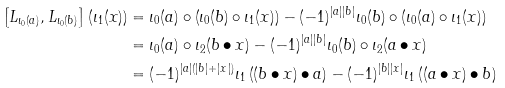<formula> <loc_0><loc_0><loc_500><loc_500>\left [ L _ { \iota _ { 0 } ( a ) } , L _ { \iota _ { 0 } ( b ) } \right ] \left ( \iota _ { 1 } ( x ) \right ) & = \iota _ { 0 } ( a ) \circ \left ( \iota _ { 0 } ( b ) \circ \iota _ { 1 } ( x ) \right ) - ( - 1 ) ^ { | a | | b | } \iota _ { 0 } ( b ) \circ \left ( \iota _ { 0 } ( a ) \circ \iota _ { 1 } ( x ) \right ) \\ & = \iota _ { 0 } ( a ) \circ \iota _ { 2 } ( b \bullet x ) - ( - 1 ) ^ { | a | | b | } \iota _ { 0 } ( b ) \circ \iota _ { 2 } ( a \bullet x ) \\ & = ( - 1 ) ^ { | a | ( | b | + | x | ) } \iota _ { 1 } \left ( ( b \bullet x ) \bullet a \right ) - ( - 1 ) ^ { | b | | x | } \iota _ { 1 } \left ( ( a \bullet x ) \bullet b \right )</formula> 